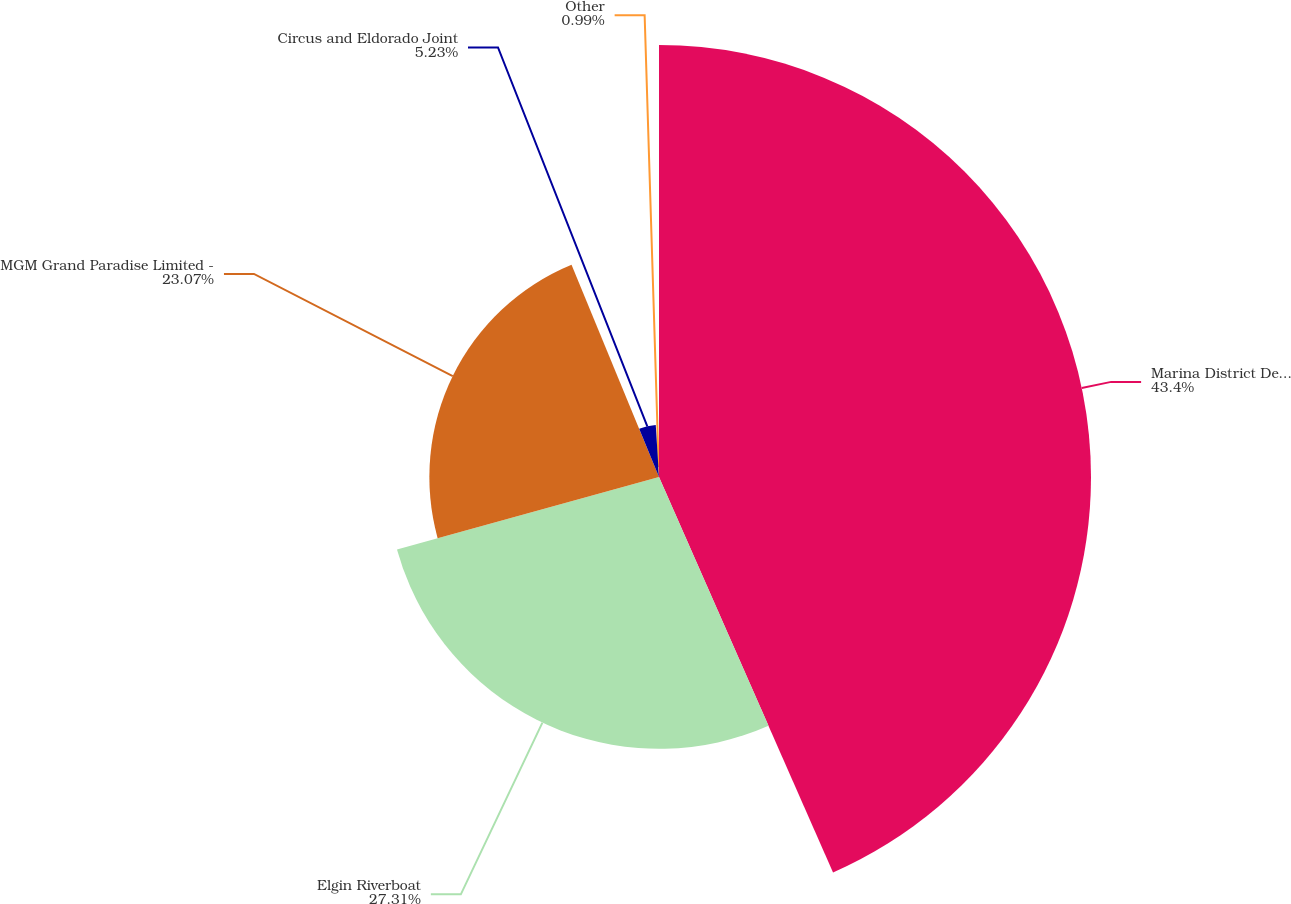Convert chart to OTSL. <chart><loc_0><loc_0><loc_500><loc_500><pie_chart><fcel>Marina District Development<fcel>Elgin Riverboat<fcel>MGM Grand Paradise Limited -<fcel>Circus and Eldorado Joint<fcel>Other<nl><fcel>43.4%<fcel>27.31%<fcel>23.07%<fcel>5.23%<fcel>0.99%<nl></chart> 